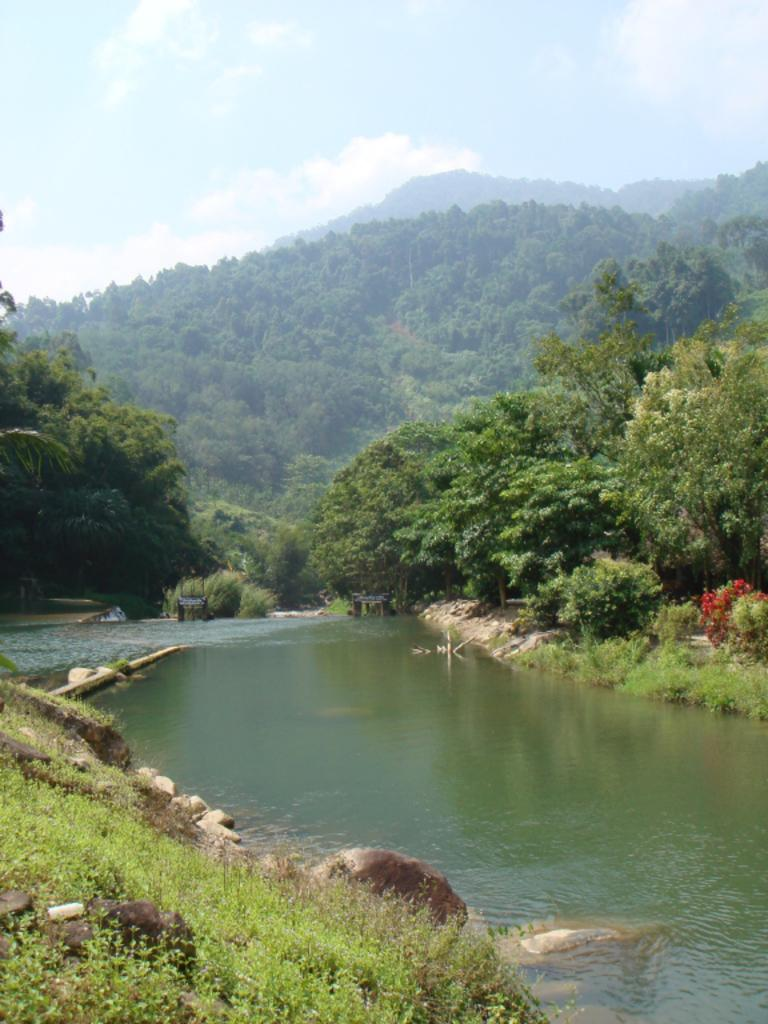What type of living organisms can be seen in the image? Plants and trees are visible in the image. What type of natural elements can be seen in the image? Stones and water are visible in the image. What else is present in the image besides plants, trees, stones, and water? There are some objects in the image. What can be seen in the background of the image? The sky is visible in the background of the image. Can you tell me how many grapes are hanging from the trees in the image? There are no grapes present in the image; it features plants and trees, but not grapes. What type of slip can be seen on the ground in the image? There is no slip present in the image; it features plants, trees, stones, water, and objects, but not a slip. 